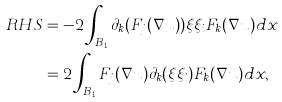Convert formula to latex. <formula><loc_0><loc_0><loc_500><loc_500>R H S & = - 2 \int _ { B _ { 1 } } \partial _ { k } ( F _ { j } ( \nabla u ) ) \xi \xi _ { i } F _ { k } ( \nabla u ) d x \\ & = 2 \int _ { B _ { 1 } } F _ { j } ( \nabla u ) \partial _ { k } ( \xi \xi _ { i } ) F _ { k } ( \nabla u ) d x ,</formula> 